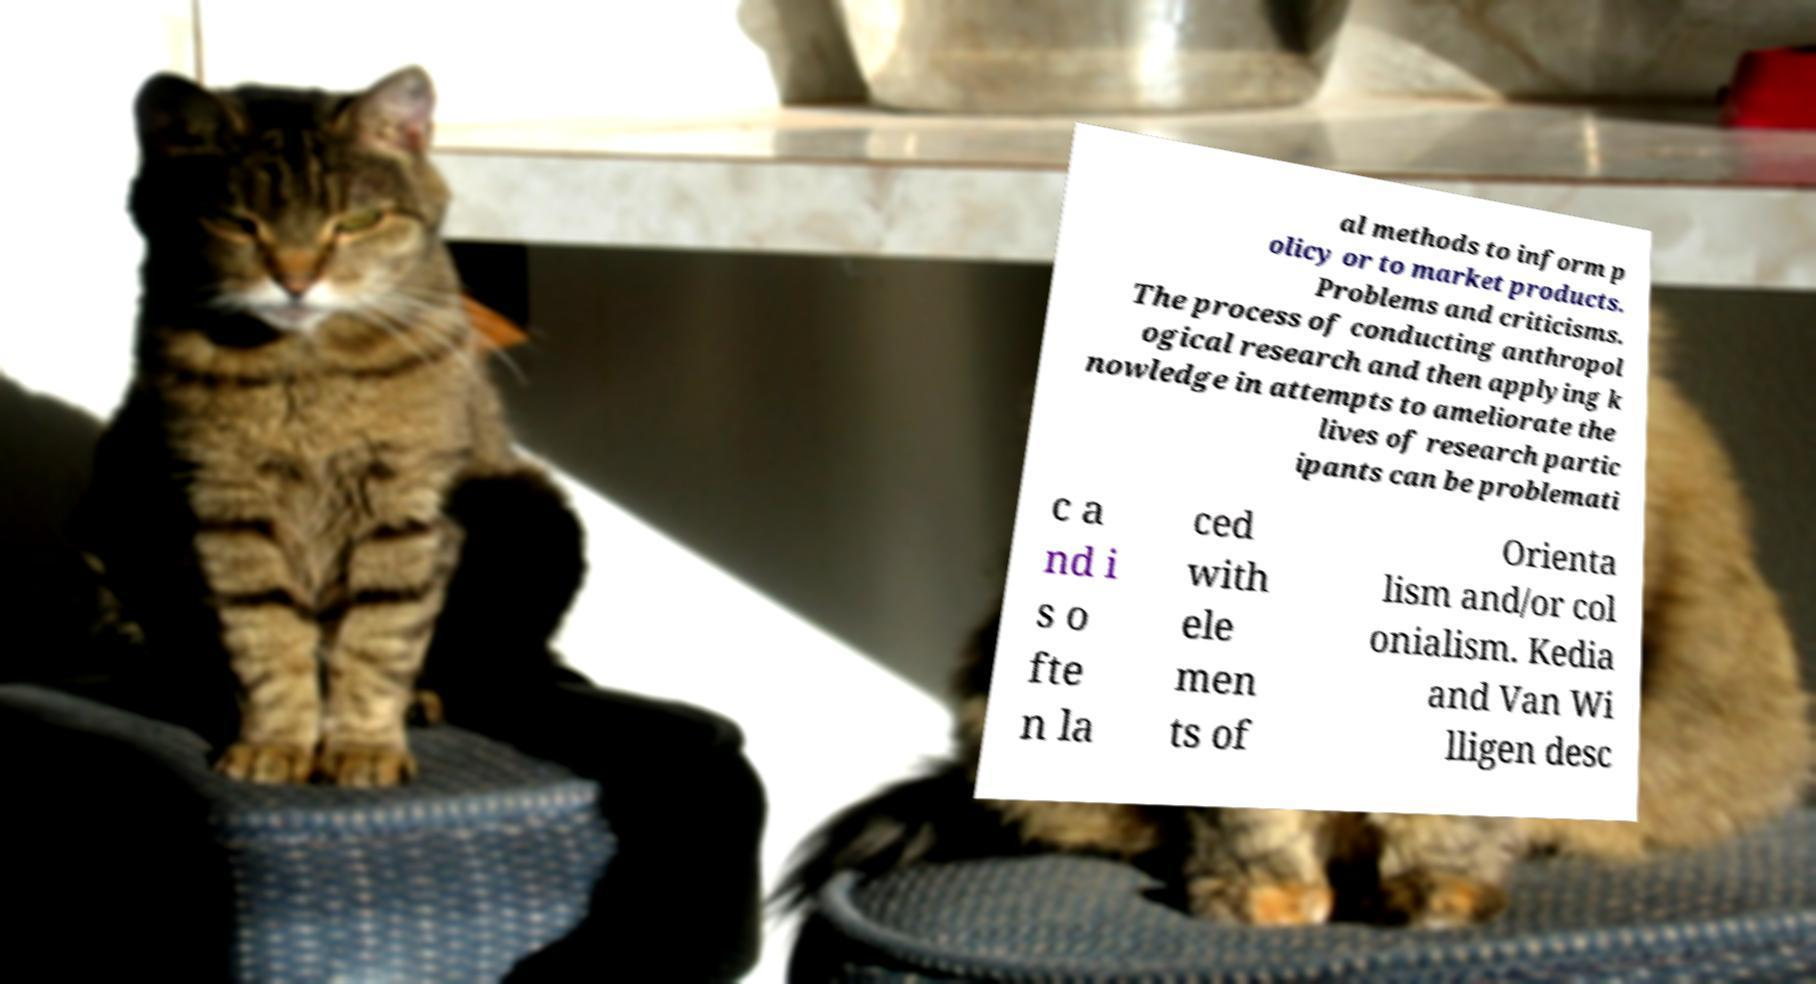Please identify and transcribe the text found in this image. al methods to inform p olicy or to market products. Problems and criticisms. The process of conducting anthropol ogical research and then applying k nowledge in attempts to ameliorate the lives of research partic ipants can be problemati c a nd i s o fte n la ced with ele men ts of Orienta lism and/or col onialism. Kedia and Van Wi lligen desc 